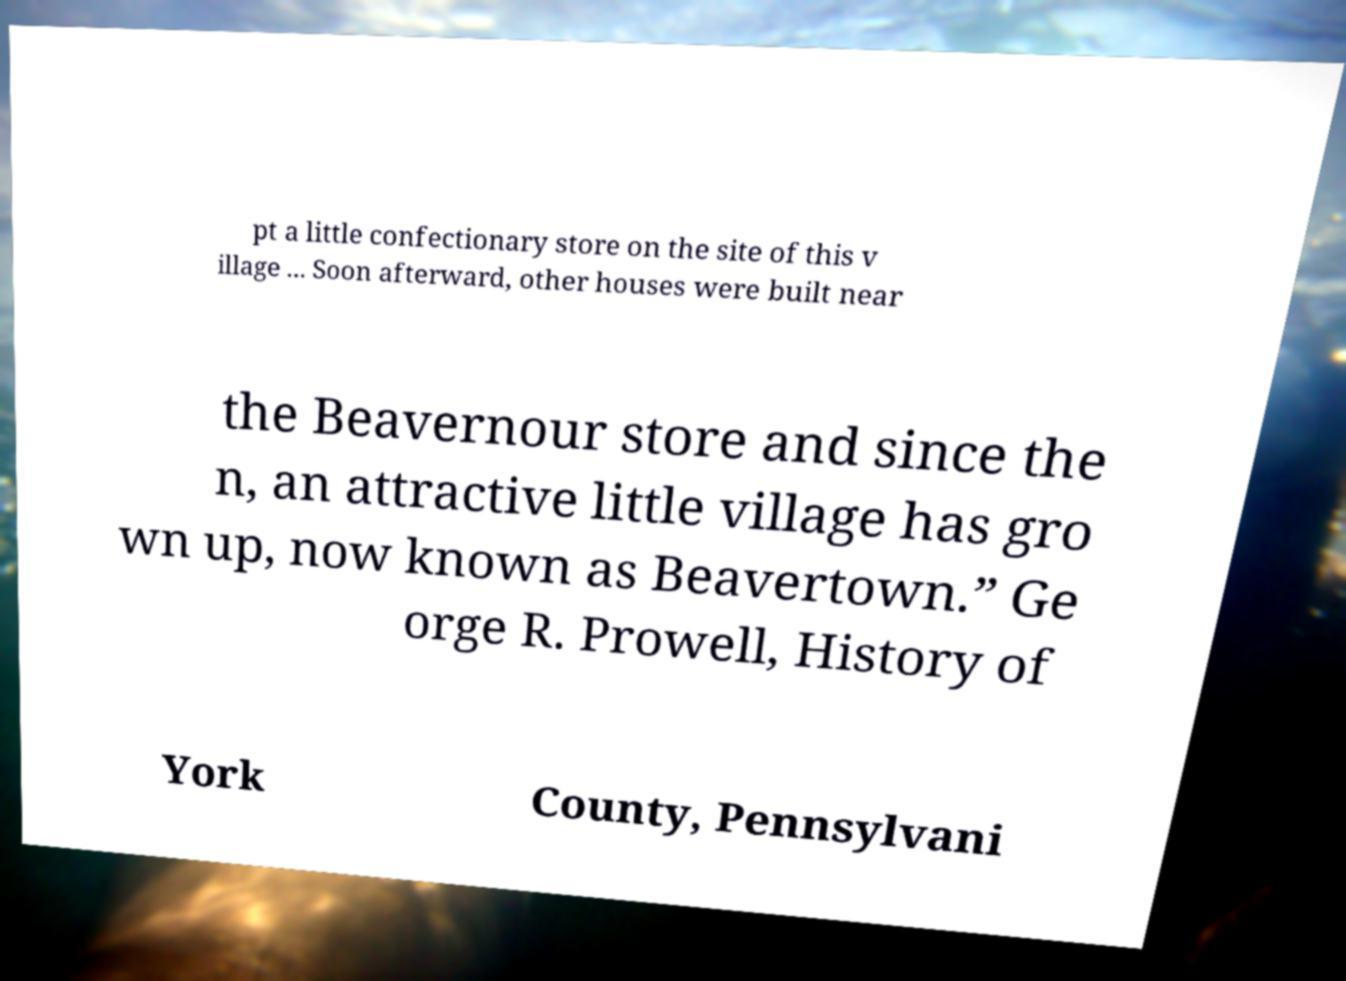For documentation purposes, I need the text within this image transcribed. Could you provide that? pt a little confectionary store on the site of this v illage ... Soon afterward, other houses were built near the Beavernour store and since the n, an attractive little village has gro wn up, now known as Beavertown.” Ge orge R. Prowell, History of York County, Pennsylvani 